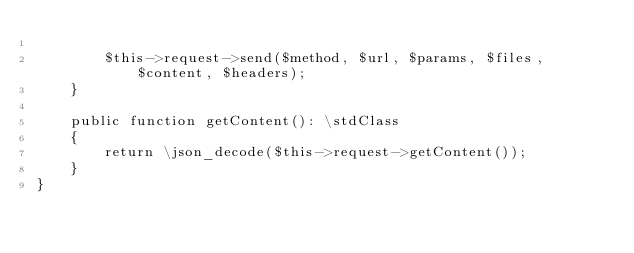Convert code to text. <code><loc_0><loc_0><loc_500><loc_500><_PHP_>
        $this->request->send($method, $url, $params, $files, $content, $headers);
    }

    public function getContent(): \stdClass
    {
        return \json_decode($this->request->getContent());
    }
}
</code> 